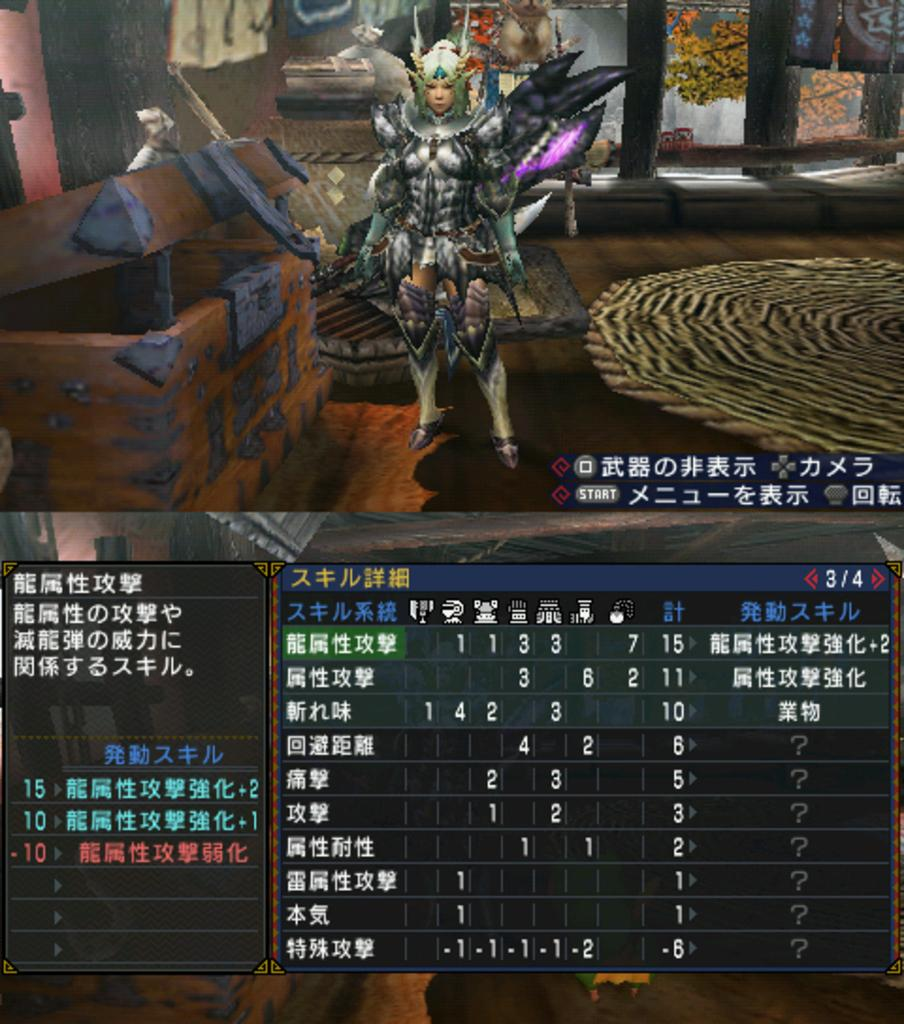<image>
Describe the image concisely. A video game screen has the number 3/4 in the blue bar above a menu of text. 